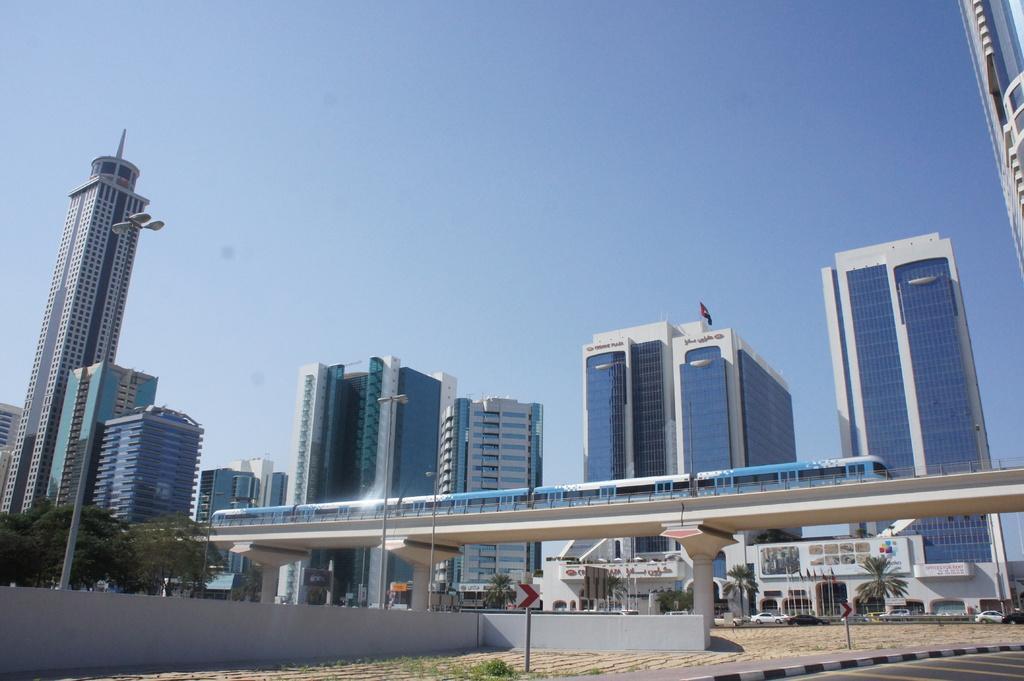Describe this image in one or two sentences. In this image we can see the train is on the bridge, trees, walls, light poles, flags, buildings, vehicles, boards and blue sky.   